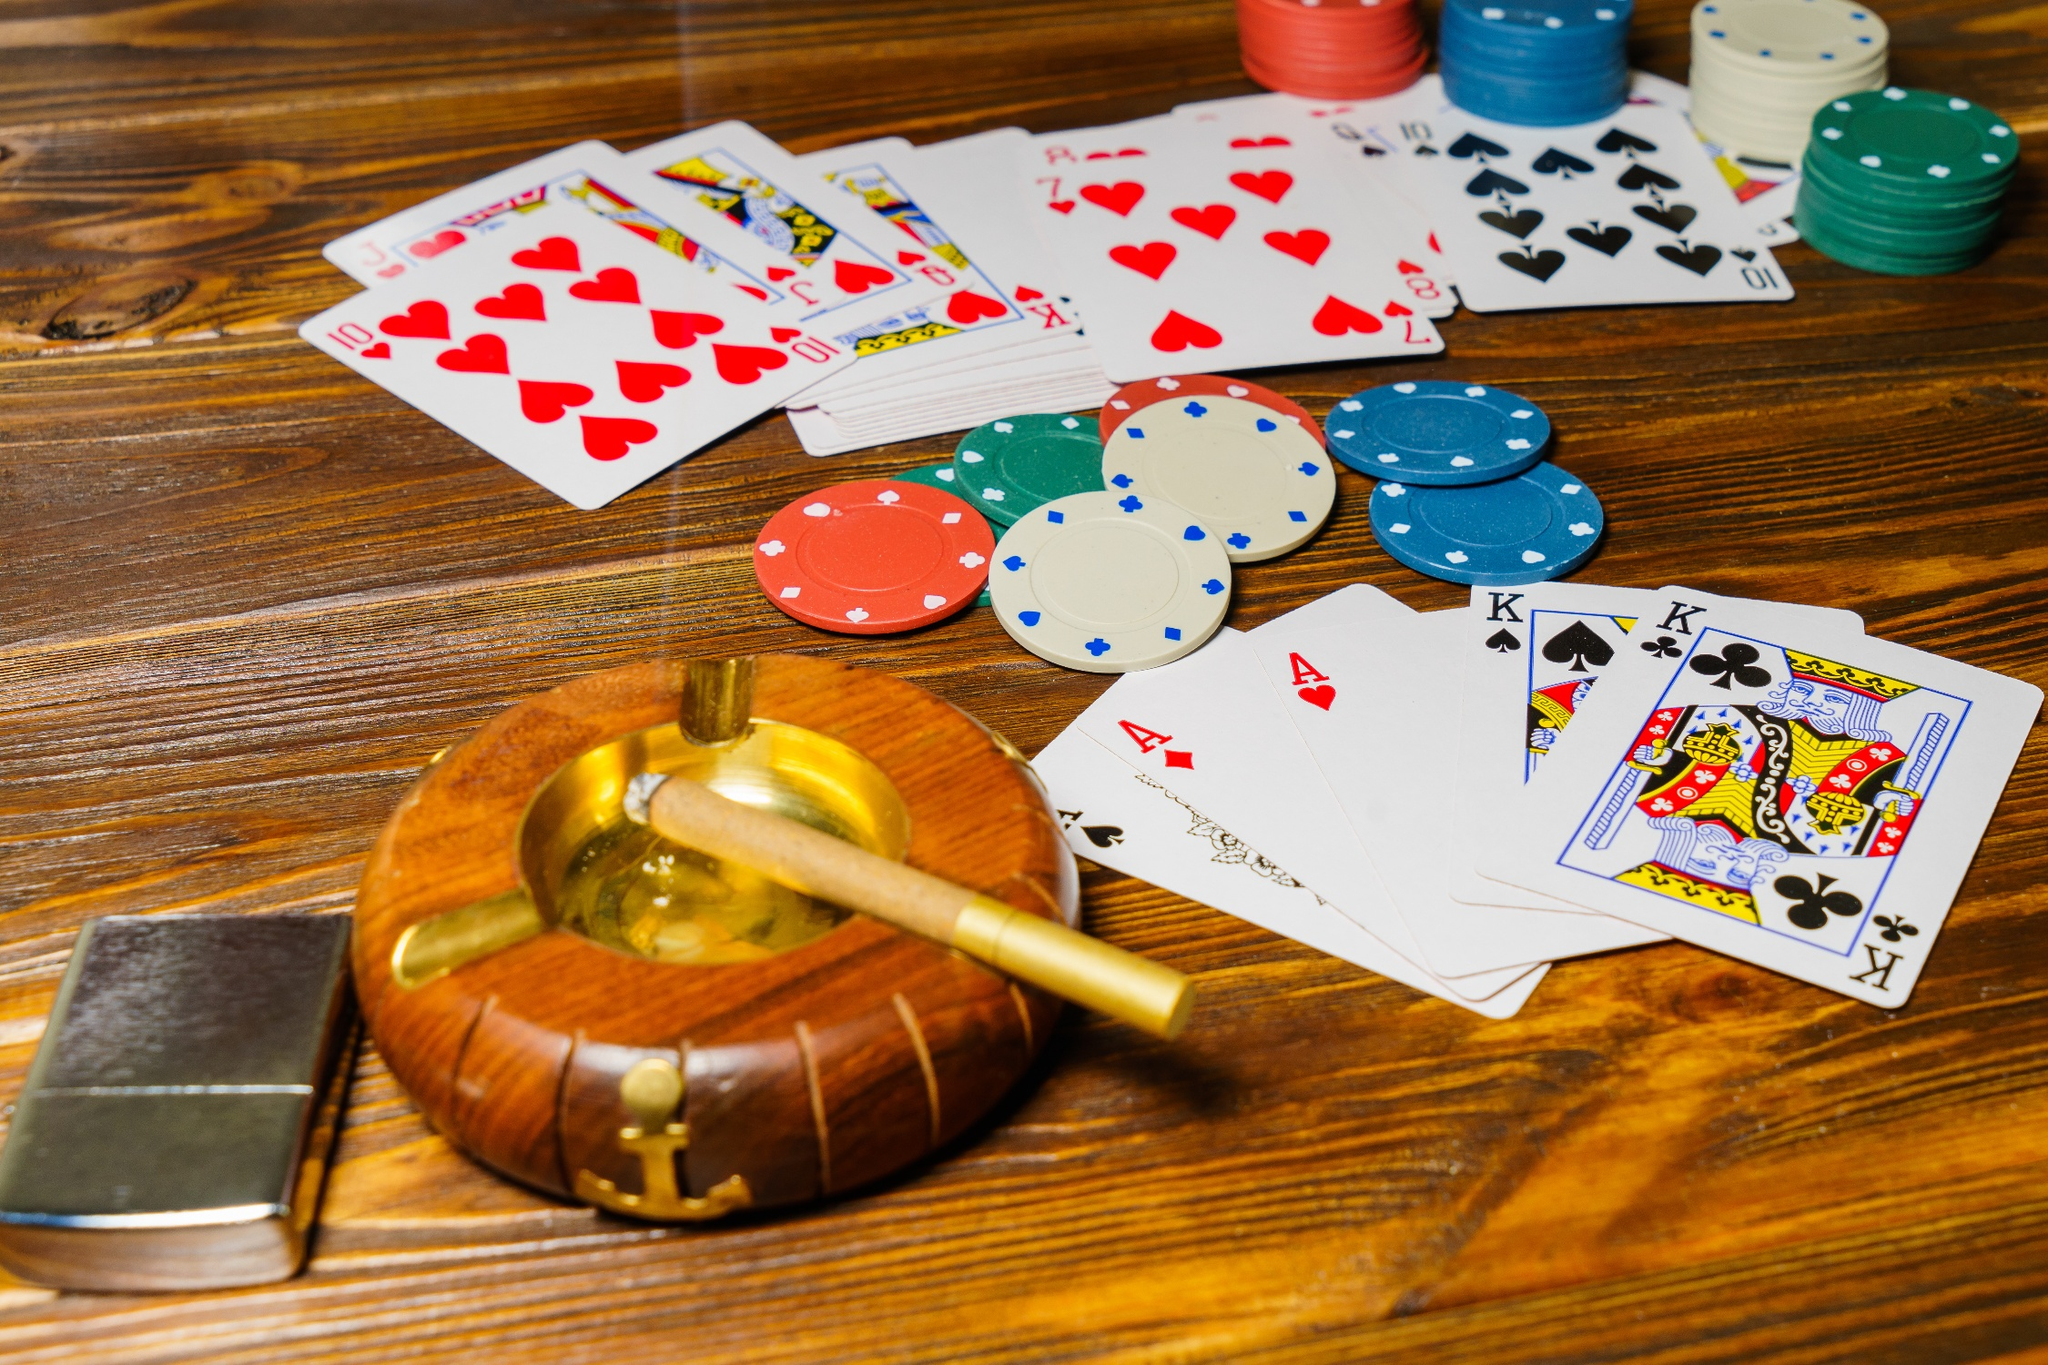Can you describe the types of poker hands visible in the image? The visible poker hands in the image reveal a variety of combinations. There is a pair of Kings (King of Spades and King of Clubs), a pair of Aces (Ace of Hearts and Ace of Clubs), several other low-value cards, and two 10s of Hearts, which suggest the possibility of a strong hand. The way the cards are arrayed hints at the strategic calculations and betting that is currently unfolding in the game. 